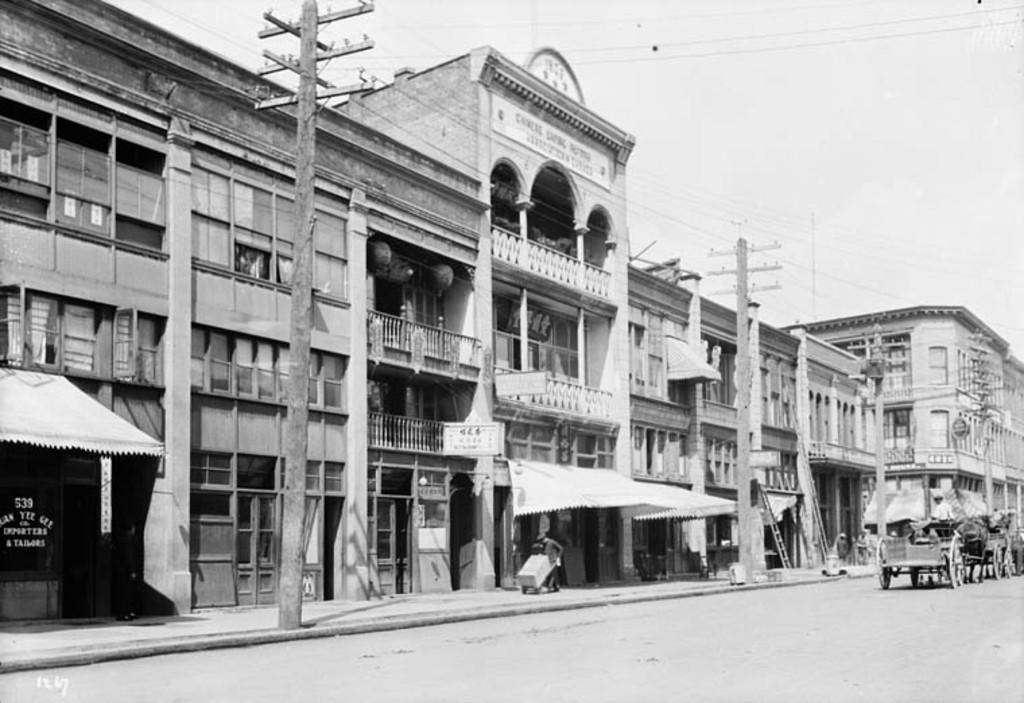What type of structures can be seen in the image? There are buildings in the image. What else can be seen in the image besides the buildings? Current poles with wires, a person holding an object, carts on the road, a shed, and a board with text are present in the image. Can you describe the person holding an object in the image? The person holding an object is visible in the image, but their specific actions or the object they are holding cannot be determined from the provided facts. What is the background of the image? The sky is visible in the background of the image. How many snakes are slithering around the person holding an object in the image? There are no snakes present in the image. What color is the doctor's coat in the image? There is no doctor present in the image, so it is not possible to determine the color of their coat. 